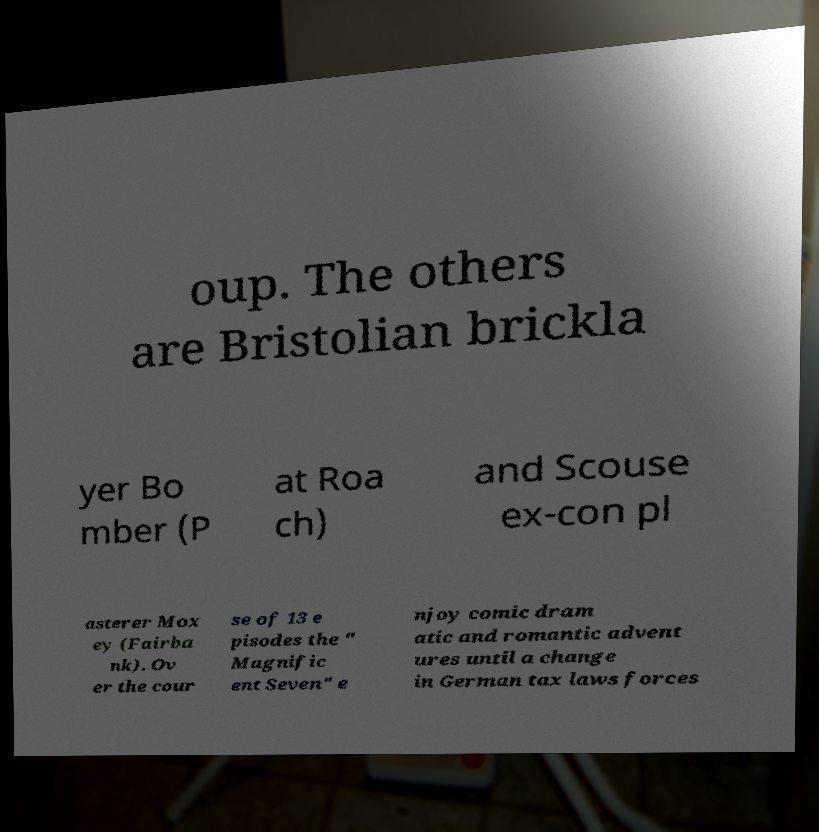For documentation purposes, I need the text within this image transcribed. Could you provide that? oup. The others are Bristolian brickla yer Bo mber (P at Roa ch) and Scouse ex-con pl asterer Mox ey (Fairba nk). Ov er the cour se of 13 e pisodes the " Magnific ent Seven" e njoy comic dram atic and romantic advent ures until a change in German tax laws forces 